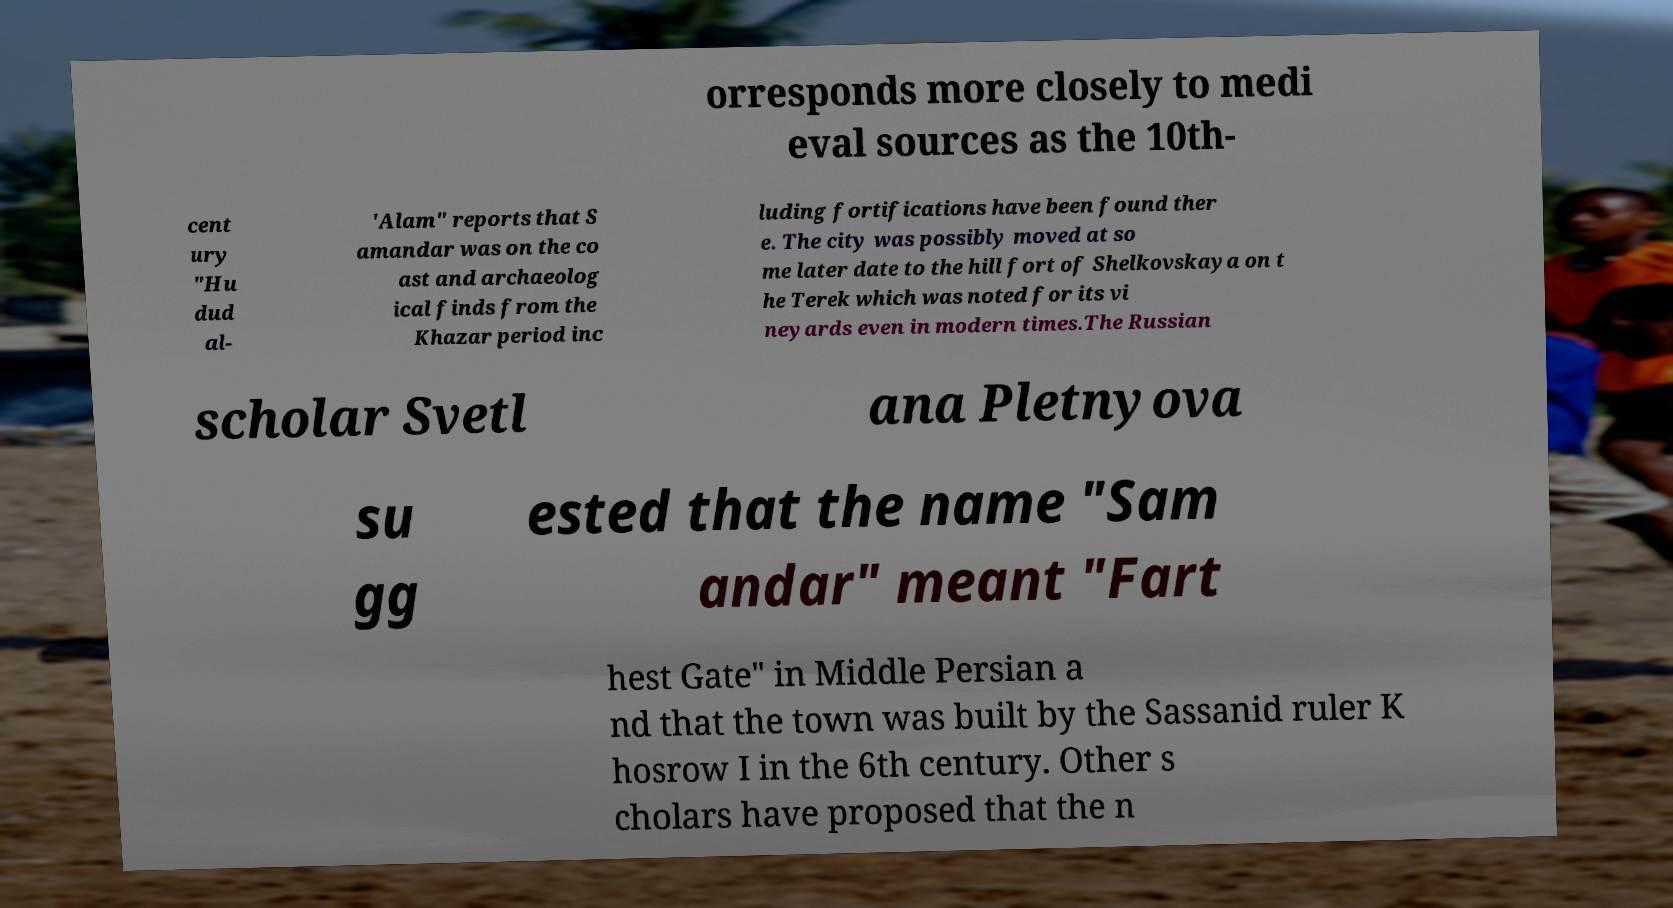Could you extract and type out the text from this image? orresponds more closely to medi eval sources as the 10th- cent ury "Hu dud al- 'Alam" reports that S amandar was on the co ast and archaeolog ical finds from the Khazar period inc luding fortifications have been found ther e. The city was possibly moved at so me later date to the hill fort of Shelkovskaya on t he Terek which was noted for its vi neyards even in modern times.The Russian scholar Svetl ana Pletnyova su gg ested that the name "Sam andar" meant "Fart hest Gate" in Middle Persian a nd that the town was built by the Sassanid ruler K hosrow I in the 6th century. Other s cholars have proposed that the n 